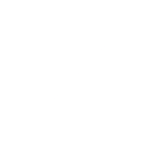Convert chart. <chart><loc_0><loc_0><loc_500><loc_500><pie_chart><fcel>(000s)<nl><fcel>100.0%<nl></chart> 